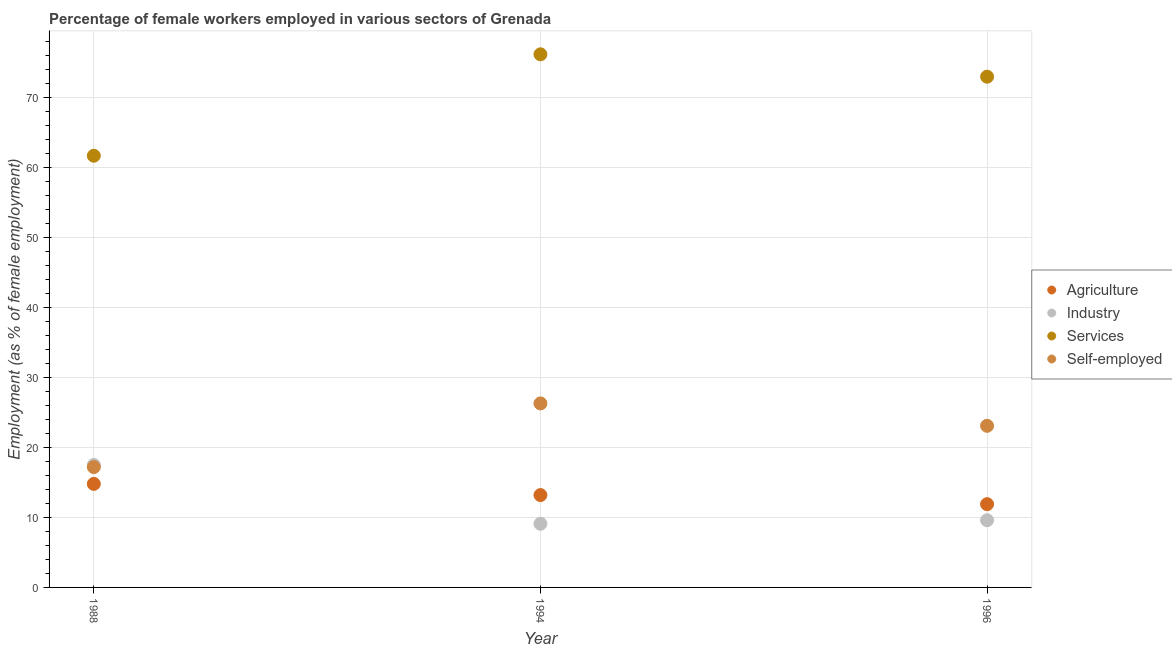Is the number of dotlines equal to the number of legend labels?
Provide a succinct answer. Yes. What is the percentage of female workers in agriculture in 1994?
Keep it short and to the point. 13.2. Across all years, what is the minimum percentage of self employed female workers?
Your response must be concise. 17.2. In which year was the percentage of female workers in services maximum?
Your answer should be very brief. 1994. What is the total percentage of female workers in agriculture in the graph?
Your response must be concise. 39.9. What is the difference between the percentage of female workers in industry in 1988 and that in 1996?
Make the answer very short. 7.9. What is the difference between the percentage of female workers in agriculture in 1988 and the percentage of female workers in industry in 1996?
Give a very brief answer. 5.2. What is the average percentage of female workers in industry per year?
Offer a very short reply. 12.07. In the year 1996, what is the difference between the percentage of female workers in industry and percentage of female workers in agriculture?
Offer a very short reply. -2.3. In how many years, is the percentage of female workers in industry greater than 14 %?
Keep it short and to the point. 1. What is the ratio of the percentage of self employed female workers in 1994 to that in 1996?
Provide a succinct answer. 1.14. Is the percentage of female workers in agriculture in 1994 less than that in 1996?
Give a very brief answer. No. Is the difference between the percentage of female workers in industry in 1988 and 1994 greater than the difference between the percentage of female workers in services in 1988 and 1994?
Your answer should be compact. Yes. What is the difference between the highest and the second highest percentage of female workers in agriculture?
Your answer should be compact. 1.6. What is the difference between the highest and the lowest percentage of self employed female workers?
Offer a terse response. 9.1. Is the sum of the percentage of female workers in agriculture in 1988 and 1994 greater than the maximum percentage of female workers in services across all years?
Make the answer very short. No. Is it the case that in every year, the sum of the percentage of female workers in services and percentage of female workers in agriculture is greater than the sum of percentage of self employed female workers and percentage of female workers in industry?
Your answer should be compact. No. Is the percentage of female workers in agriculture strictly less than the percentage of female workers in services over the years?
Keep it short and to the point. Yes. How many dotlines are there?
Offer a very short reply. 4. Are the values on the major ticks of Y-axis written in scientific E-notation?
Your answer should be compact. No. Does the graph contain any zero values?
Provide a succinct answer. No. Does the graph contain grids?
Ensure brevity in your answer.  Yes. How are the legend labels stacked?
Ensure brevity in your answer.  Vertical. What is the title of the graph?
Offer a very short reply. Percentage of female workers employed in various sectors of Grenada. Does "Secondary general" appear as one of the legend labels in the graph?
Give a very brief answer. No. What is the label or title of the Y-axis?
Make the answer very short. Employment (as % of female employment). What is the Employment (as % of female employment) in Agriculture in 1988?
Offer a very short reply. 14.8. What is the Employment (as % of female employment) in Services in 1988?
Your response must be concise. 61.7. What is the Employment (as % of female employment) in Self-employed in 1988?
Provide a succinct answer. 17.2. What is the Employment (as % of female employment) in Agriculture in 1994?
Make the answer very short. 13.2. What is the Employment (as % of female employment) in Industry in 1994?
Offer a very short reply. 9.1. What is the Employment (as % of female employment) in Services in 1994?
Offer a very short reply. 76.2. What is the Employment (as % of female employment) in Self-employed in 1994?
Your answer should be compact. 26.3. What is the Employment (as % of female employment) in Agriculture in 1996?
Your response must be concise. 11.9. What is the Employment (as % of female employment) of Industry in 1996?
Your answer should be very brief. 9.6. What is the Employment (as % of female employment) in Services in 1996?
Give a very brief answer. 73. What is the Employment (as % of female employment) in Self-employed in 1996?
Your answer should be very brief. 23.1. Across all years, what is the maximum Employment (as % of female employment) of Agriculture?
Your answer should be compact. 14.8. Across all years, what is the maximum Employment (as % of female employment) of Services?
Provide a succinct answer. 76.2. Across all years, what is the maximum Employment (as % of female employment) of Self-employed?
Keep it short and to the point. 26.3. Across all years, what is the minimum Employment (as % of female employment) of Agriculture?
Keep it short and to the point. 11.9. Across all years, what is the minimum Employment (as % of female employment) in Industry?
Your answer should be very brief. 9.1. Across all years, what is the minimum Employment (as % of female employment) of Services?
Your answer should be compact. 61.7. Across all years, what is the minimum Employment (as % of female employment) of Self-employed?
Give a very brief answer. 17.2. What is the total Employment (as % of female employment) of Agriculture in the graph?
Provide a succinct answer. 39.9. What is the total Employment (as % of female employment) of Industry in the graph?
Provide a succinct answer. 36.2. What is the total Employment (as % of female employment) in Services in the graph?
Keep it short and to the point. 210.9. What is the total Employment (as % of female employment) in Self-employed in the graph?
Ensure brevity in your answer.  66.6. What is the difference between the Employment (as % of female employment) in Industry in 1988 and that in 1994?
Give a very brief answer. 8.4. What is the difference between the Employment (as % of female employment) in Services in 1988 and that in 1994?
Give a very brief answer. -14.5. What is the difference between the Employment (as % of female employment) of Agriculture in 1988 and that in 1996?
Provide a short and direct response. 2.9. What is the difference between the Employment (as % of female employment) in Agriculture in 1994 and that in 1996?
Offer a terse response. 1.3. What is the difference between the Employment (as % of female employment) in Agriculture in 1988 and the Employment (as % of female employment) in Services in 1994?
Keep it short and to the point. -61.4. What is the difference between the Employment (as % of female employment) of Agriculture in 1988 and the Employment (as % of female employment) of Self-employed in 1994?
Give a very brief answer. -11.5. What is the difference between the Employment (as % of female employment) in Industry in 1988 and the Employment (as % of female employment) in Services in 1994?
Provide a short and direct response. -58.7. What is the difference between the Employment (as % of female employment) of Services in 1988 and the Employment (as % of female employment) of Self-employed in 1994?
Your answer should be very brief. 35.4. What is the difference between the Employment (as % of female employment) of Agriculture in 1988 and the Employment (as % of female employment) of Industry in 1996?
Provide a short and direct response. 5.2. What is the difference between the Employment (as % of female employment) in Agriculture in 1988 and the Employment (as % of female employment) in Services in 1996?
Your response must be concise. -58.2. What is the difference between the Employment (as % of female employment) in Industry in 1988 and the Employment (as % of female employment) in Services in 1996?
Give a very brief answer. -55.5. What is the difference between the Employment (as % of female employment) in Services in 1988 and the Employment (as % of female employment) in Self-employed in 1996?
Give a very brief answer. 38.6. What is the difference between the Employment (as % of female employment) in Agriculture in 1994 and the Employment (as % of female employment) in Industry in 1996?
Ensure brevity in your answer.  3.6. What is the difference between the Employment (as % of female employment) in Agriculture in 1994 and the Employment (as % of female employment) in Services in 1996?
Offer a very short reply. -59.8. What is the difference between the Employment (as % of female employment) in Industry in 1994 and the Employment (as % of female employment) in Services in 1996?
Provide a short and direct response. -63.9. What is the difference between the Employment (as % of female employment) in Services in 1994 and the Employment (as % of female employment) in Self-employed in 1996?
Your answer should be compact. 53.1. What is the average Employment (as % of female employment) in Agriculture per year?
Your response must be concise. 13.3. What is the average Employment (as % of female employment) of Industry per year?
Keep it short and to the point. 12.07. What is the average Employment (as % of female employment) of Services per year?
Provide a succinct answer. 70.3. What is the average Employment (as % of female employment) of Self-employed per year?
Offer a very short reply. 22.2. In the year 1988, what is the difference between the Employment (as % of female employment) in Agriculture and Employment (as % of female employment) in Services?
Give a very brief answer. -46.9. In the year 1988, what is the difference between the Employment (as % of female employment) in Industry and Employment (as % of female employment) in Services?
Ensure brevity in your answer.  -44.2. In the year 1988, what is the difference between the Employment (as % of female employment) in Industry and Employment (as % of female employment) in Self-employed?
Ensure brevity in your answer.  0.3. In the year 1988, what is the difference between the Employment (as % of female employment) of Services and Employment (as % of female employment) of Self-employed?
Offer a terse response. 44.5. In the year 1994, what is the difference between the Employment (as % of female employment) of Agriculture and Employment (as % of female employment) of Services?
Ensure brevity in your answer.  -63. In the year 1994, what is the difference between the Employment (as % of female employment) of Agriculture and Employment (as % of female employment) of Self-employed?
Keep it short and to the point. -13.1. In the year 1994, what is the difference between the Employment (as % of female employment) in Industry and Employment (as % of female employment) in Services?
Offer a very short reply. -67.1. In the year 1994, what is the difference between the Employment (as % of female employment) of Industry and Employment (as % of female employment) of Self-employed?
Your answer should be very brief. -17.2. In the year 1994, what is the difference between the Employment (as % of female employment) of Services and Employment (as % of female employment) of Self-employed?
Offer a terse response. 49.9. In the year 1996, what is the difference between the Employment (as % of female employment) of Agriculture and Employment (as % of female employment) of Services?
Provide a succinct answer. -61.1. In the year 1996, what is the difference between the Employment (as % of female employment) in Industry and Employment (as % of female employment) in Services?
Give a very brief answer. -63.4. In the year 1996, what is the difference between the Employment (as % of female employment) in Services and Employment (as % of female employment) in Self-employed?
Ensure brevity in your answer.  49.9. What is the ratio of the Employment (as % of female employment) in Agriculture in 1988 to that in 1994?
Your answer should be very brief. 1.12. What is the ratio of the Employment (as % of female employment) in Industry in 1988 to that in 1994?
Your answer should be very brief. 1.92. What is the ratio of the Employment (as % of female employment) of Services in 1988 to that in 1994?
Offer a terse response. 0.81. What is the ratio of the Employment (as % of female employment) of Self-employed in 1988 to that in 1994?
Provide a succinct answer. 0.65. What is the ratio of the Employment (as % of female employment) in Agriculture in 1988 to that in 1996?
Your response must be concise. 1.24. What is the ratio of the Employment (as % of female employment) of Industry in 1988 to that in 1996?
Offer a terse response. 1.82. What is the ratio of the Employment (as % of female employment) of Services in 1988 to that in 1996?
Your answer should be very brief. 0.85. What is the ratio of the Employment (as % of female employment) of Self-employed in 1988 to that in 1996?
Offer a very short reply. 0.74. What is the ratio of the Employment (as % of female employment) in Agriculture in 1994 to that in 1996?
Offer a terse response. 1.11. What is the ratio of the Employment (as % of female employment) of Industry in 1994 to that in 1996?
Ensure brevity in your answer.  0.95. What is the ratio of the Employment (as % of female employment) of Services in 1994 to that in 1996?
Ensure brevity in your answer.  1.04. What is the ratio of the Employment (as % of female employment) in Self-employed in 1994 to that in 1996?
Ensure brevity in your answer.  1.14. What is the difference between the highest and the second highest Employment (as % of female employment) of Industry?
Give a very brief answer. 7.9. What is the difference between the highest and the second highest Employment (as % of female employment) in Services?
Provide a succinct answer. 3.2. What is the difference between the highest and the lowest Employment (as % of female employment) of Agriculture?
Offer a very short reply. 2.9. What is the difference between the highest and the lowest Employment (as % of female employment) of Self-employed?
Make the answer very short. 9.1. 